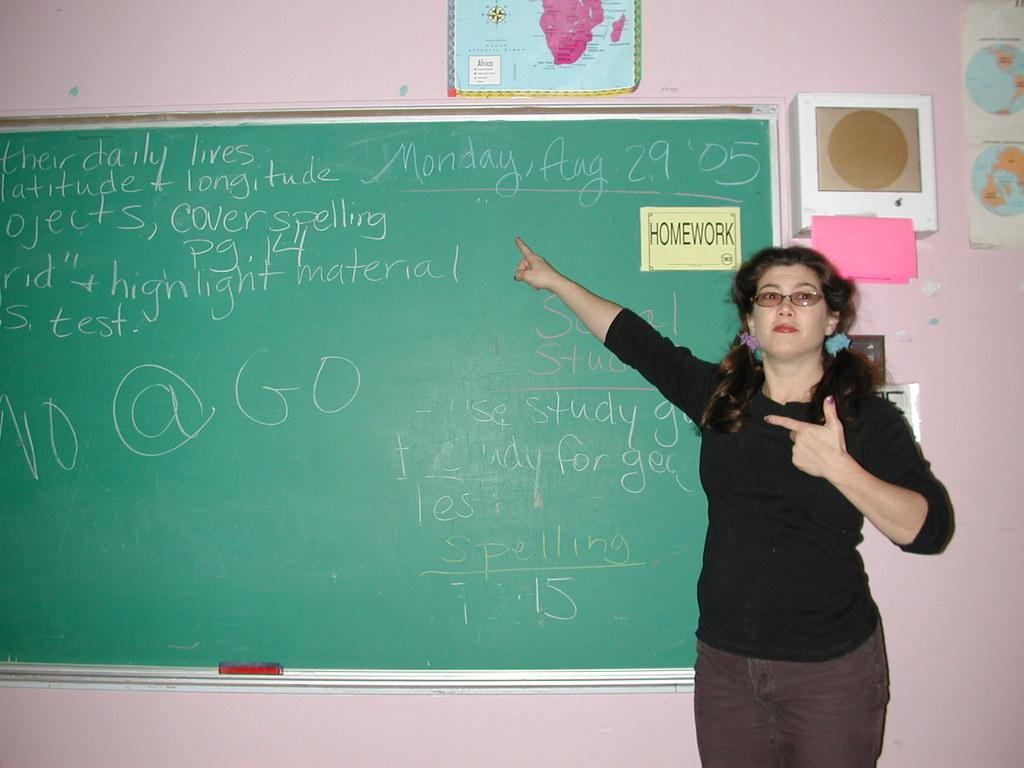What is the main subject in the image? There is a woman standing in the image. What else can be seen in the image besides the woman? There is a board with text written on it and papers pasted on the wall in the image. How many sacks can be seen in the image? There are no sacks present in the image. What type of trains are visible in the image? There are no trains present in the image. 